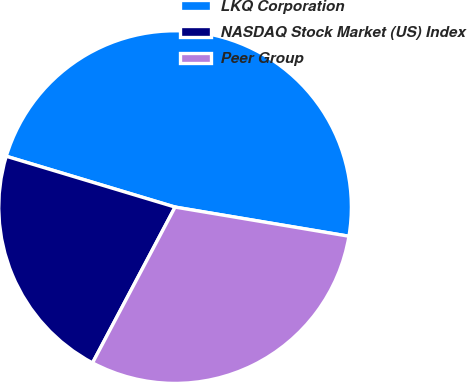Convert chart. <chart><loc_0><loc_0><loc_500><loc_500><pie_chart><fcel>LKQ Corporation<fcel>NASDAQ Stock Market (US) Index<fcel>Peer Group<nl><fcel>47.99%<fcel>21.9%<fcel>30.11%<nl></chart> 